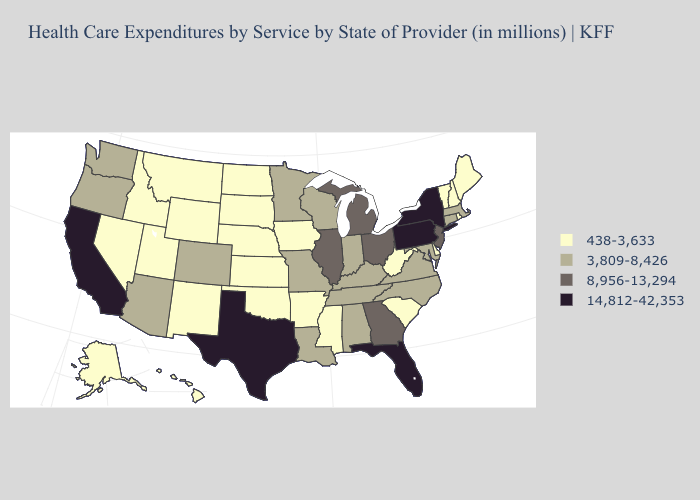Does Nebraska have the highest value in the MidWest?
Answer briefly. No. Which states have the lowest value in the USA?
Keep it brief. Alaska, Arkansas, Delaware, Hawaii, Idaho, Iowa, Kansas, Maine, Mississippi, Montana, Nebraska, Nevada, New Hampshire, New Mexico, North Dakota, Oklahoma, Rhode Island, South Carolina, South Dakota, Utah, Vermont, West Virginia, Wyoming. Does New York have the highest value in the Northeast?
Quick response, please. Yes. What is the value of Mississippi?
Quick response, please. 438-3,633. Among the states that border Connecticut , which have the highest value?
Keep it brief. New York. Is the legend a continuous bar?
Quick response, please. No. What is the value of Montana?
Answer briefly. 438-3,633. Does Connecticut have the highest value in the Northeast?
Answer briefly. No. What is the lowest value in the USA?
Short answer required. 438-3,633. Does Kansas have the same value as Idaho?
Quick response, please. Yes. Which states hav the highest value in the South?
Give a very brief answer. Florida, Texas. Which states have the lowest value in the South?
Concise answer only. Arkansas, Delaware, Mississippi, Oklahoma, South Carolina, West Virginia. What is the value of Kentucky?
Write a very short answer. 3,809-8,426. Among the states that border Vermont , which have the highest value?
Short answer required. New York. Name the states that have a value in the range 3,809-8,426?
Short answer required. Alabama, Arizona, Colorado, Connecticut, Indiana, Kentucky, Louisiana, Maryland, Massachusetts, Minnesota, Missouri, North Carolina, Oregon, Tennessee, Virginia, Washington, Wisconsin. 